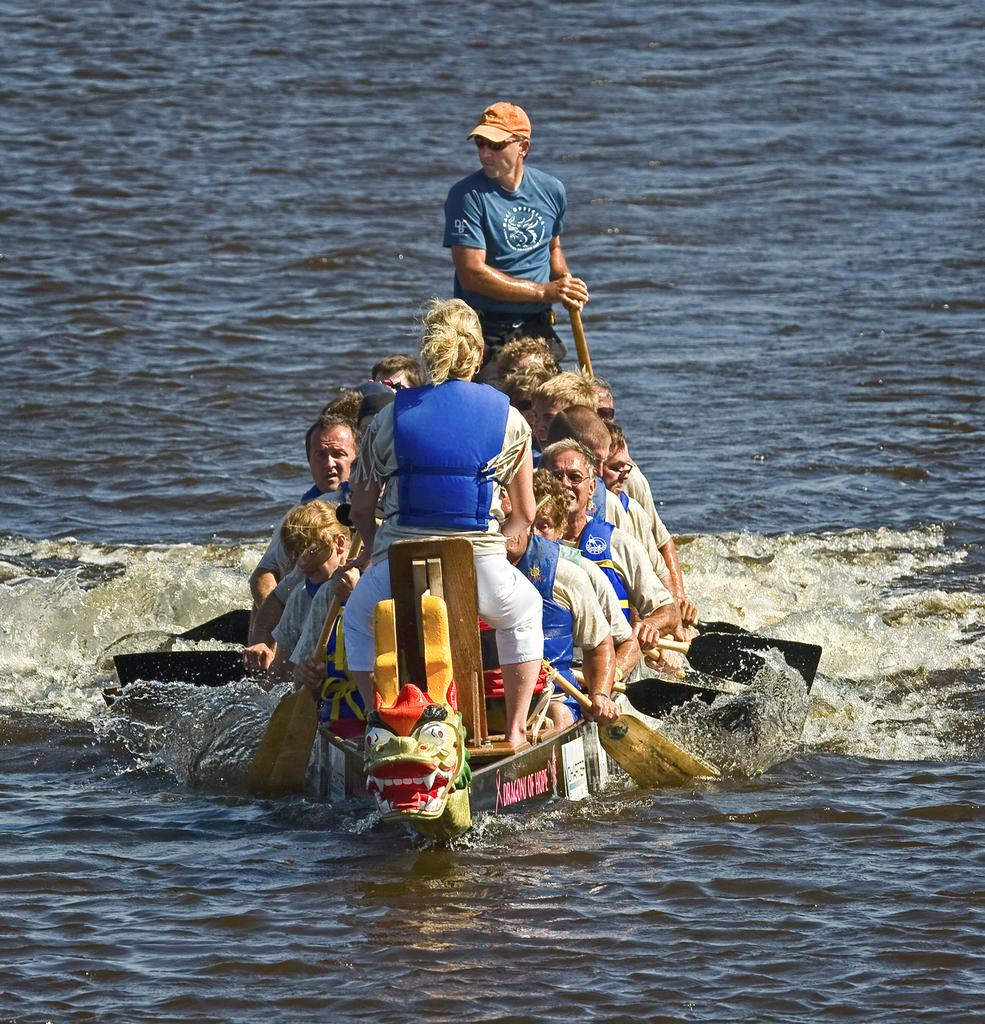What are the persons in the image doing? The persons in the image are sitting in a boat and rowing it. What is the location of the boat in the image? The boat is on an ocean, as it is visible in the background of the image. What type of space exploration equipment can be seen in the image? There is no space exploration equipment present in the image; it features persons in a boat on an ocean. What thoughts are the persons in the boat having in the image? The image does not provide information about the thoughts of the persons in the boat. 